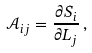<formula> <loc_0><loc_0><loc_500><loc_500>\mathcal { A } _ { i j } = \frac { \partial S _ { i } } { \partial L _ { j } } \, ,</formula> 